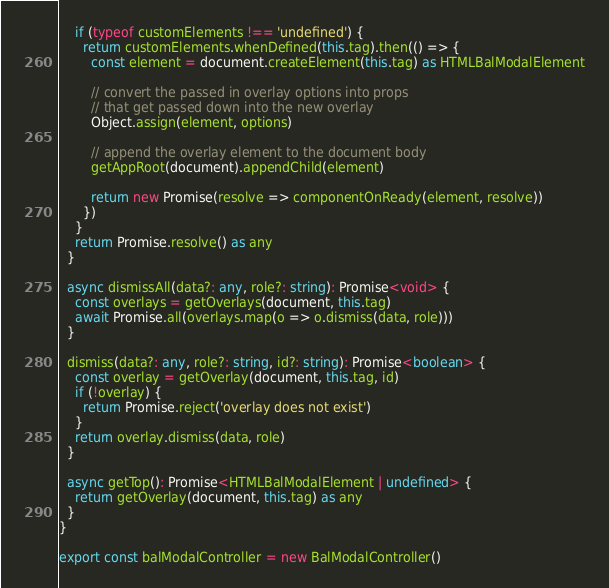<code> <loc_0><loc_0><loc_500><loc_500><_TypeScript_>    if (typeof customElements !== 'undefined') {
      return customElements.whenDefined(this.tag).then(() => {
        const element = document.createElement(this.tag) as HTMLBalModalElement

        // convert the passed in overlay options into props
        // that get passed down into the new overlay
        Object.assign(element, options)

        // append the overlay element to the document body
        getAppRoot(document).appendChild(element)

        return new Promise(resolve => componentOnReady(element, resolve))
      })
    }
    return Promise.resolve() as any
  }

  async dismissAll(data?: any, role?: string): Promise<void> {
    const overlays = getOverlays(document, this.tag)
    await Promise.all(overlays.map(o => o.dismiss(data, role)))
  }

  dismiss(data?: any, role?: string, id?: string): Promise<boolean> {
    const overlay = getOverlay(document, this.tag, id)
    if (!overlay) {
      return Promise.reject('overlay does not exist')
    }
    return overlay.dismiss(data, role)
  }

  async getTop(): Promise<HTMLBalModalElement | undefined> {
    return getOverlay(document, this.tag) as any
  }
}

export const balModalController = new BalModalController()
</code> 